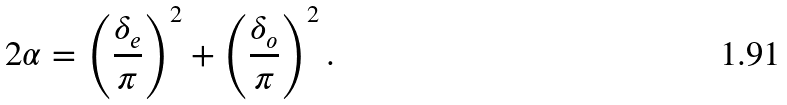<formula> <loc_0><loc_0><loc_500><loc_500>2 \alpha = \left ( \frac { \delta _ { e } } { \pi } \right ) ^ { 2 } + \left ( \frac { \delta _ { o } } { \pi } \right ) ^ { 2 } .</formula> 